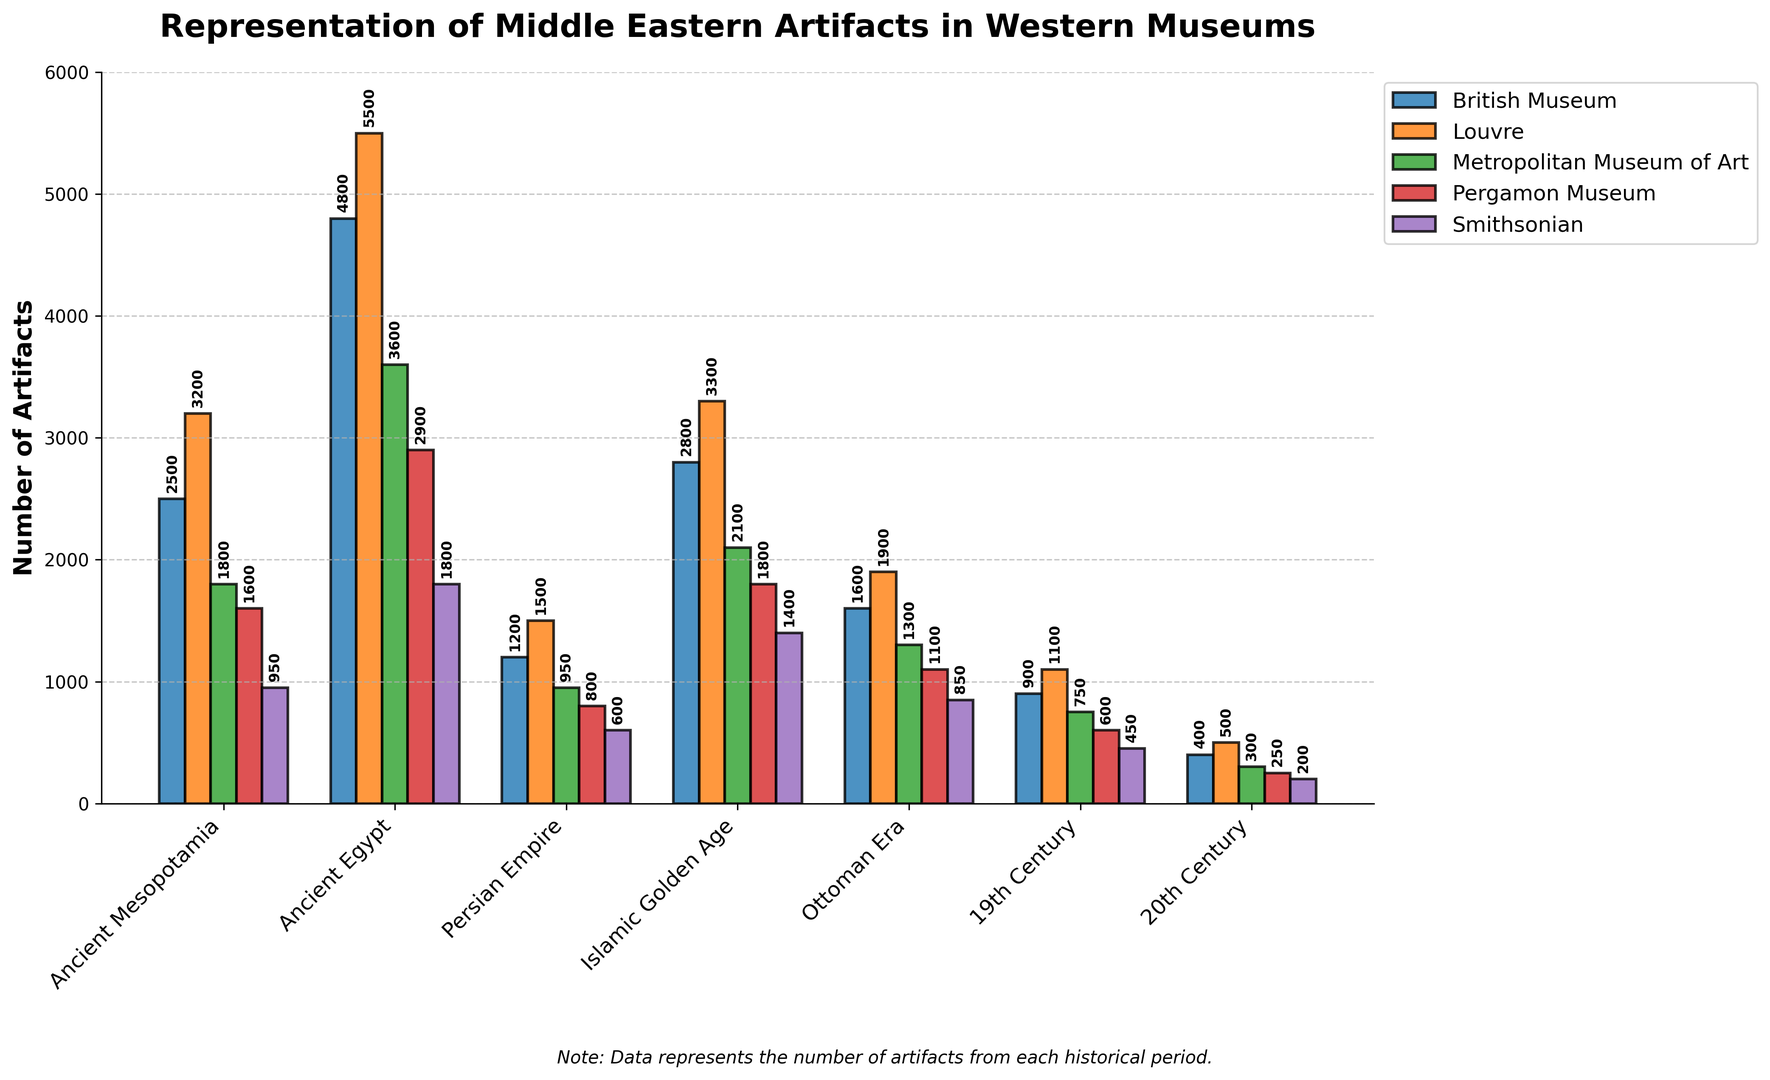What historical period has the highest representation of artifacts in the Louvre? To answer this, look for the highest bar among the different periods for the Louvre museum, which is usually represented visually by a specific color.
Answer: Ancient Egypt Which museum has the least representation of artifacts from the 20th Century? Identify the bars corresponding to the 20th Century across all museums and find the shortest one.
Answer: Smithsonian What is the total number of artifacts from the Ancient Mesopotamia period across all museums? Sum the values associated with each museum for the Ancient Mesopotamia period: 2500 (British Museum) + 3200 (Louvre) + 1800 (Metropolitan Museum of Art) + 1600 (Pergamon Museum) + 950 (Smithsonian) = 10050.
Answer: 10050 Compare the representation of artifacts from the Islamic Golden Age and the Ottoman Era in the British Museum. Which period has more artifacts? Look at the heights of the bars representing these two periods in the British Museum. The Islamic Golden Age bar (2800) is higher than the Ottoman Era bar (1600).
Answer: Islamic Golden Age Which historical period has the most even distribution of artifacts across all five museums? To determine this, visually assess which period has bars of similar heights across all museums. The 20th Century appears to have evenly distributed bars.
Answer: 20th Century What is the difference in the number of artifacts from the Persian Empire between the Louvre and the Pergamon Museum? Subtract the value of the Pergamon Museum (800) from the value of the Louvre (1500) for the Persian Empire period: 1500 - 800 = 700.
Answer: 700 Which period has a smaller representation in the Metropolitan Museum of Art compared to the British Museum and also in the Smithsonian compared to the Pergamon Museum? Look for a period where both conditions are true. The Persian Empire period fits this criterion: 950 (Metropolitan) < 1200 (British) and 600 (Smithsonian) < 800 (Pergamon).
Answer: Persian Empire 